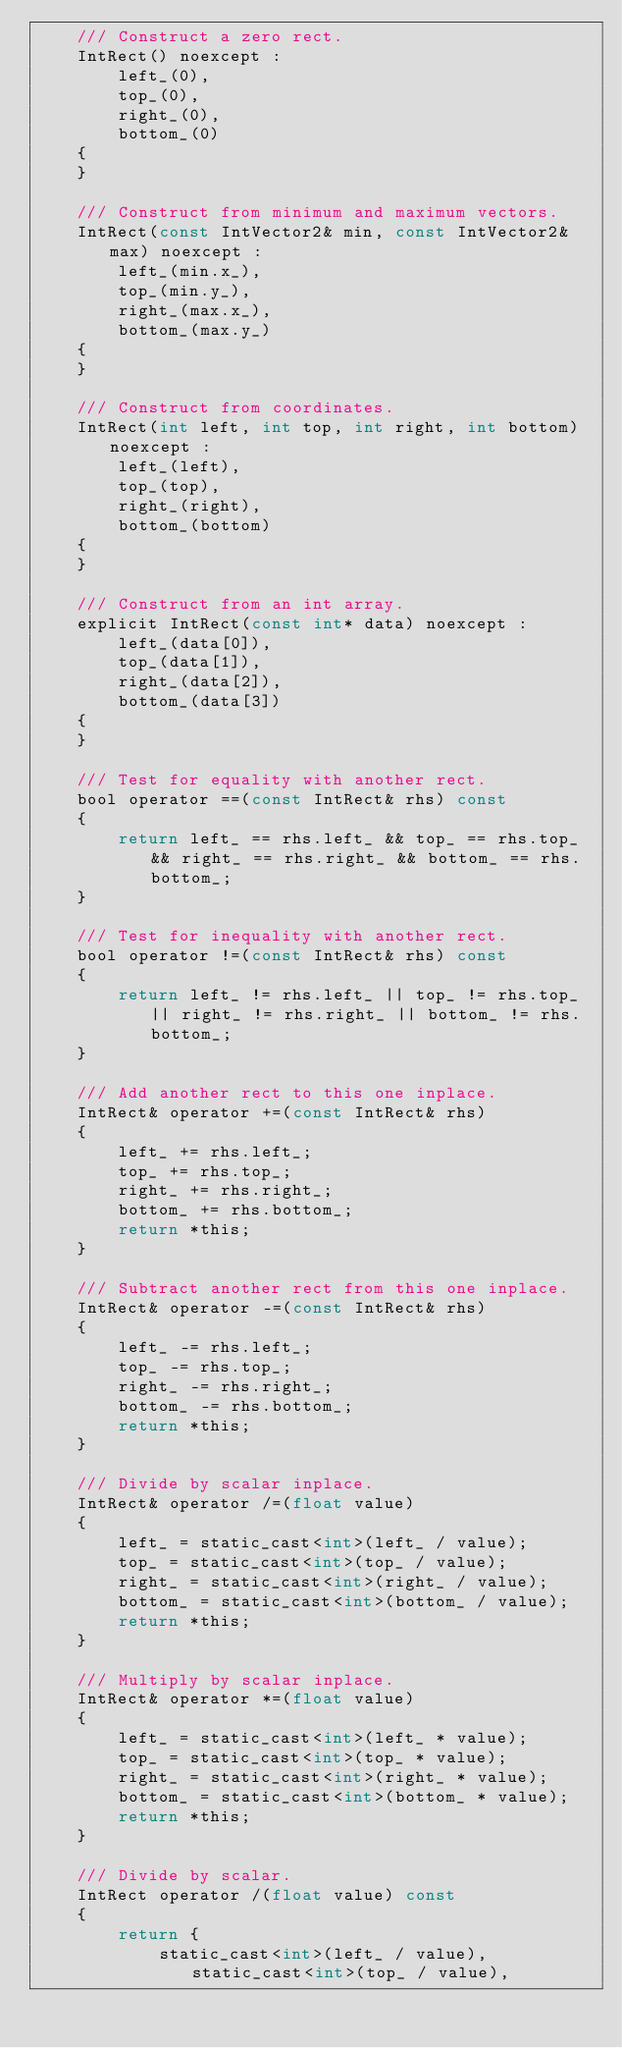<code> <loc_0><loc_0><loc_500><loc_500><_C_>    /// Construct a zero rect.
    IntRect() noexcept :
        left_(0),
        top_(0),
        right_(0),
        bottom_(0)
    {
    }

    /// Construct from minimum and maximum vectors.
    IntRect(const IntVector2& min, const IntVector2& max) noexcept :
        left_(min.x_),
        top_(min.y_),
        right_(max.x_),
        bottom_(max.y_)
    {
    }

    /// Construct from coordinates.
    IntRect(int left, int top, int right, int bottom) noexcept :
        left_(left),
        top_(top),
        right_(right),
        bottom_(bottom)
    {
    }

    /// Construct from an int array.
    explicit IntRect(const int* data) noexcept :
        left_(data[0]),
        top_(data[1]),
        right_(data[2]),
        bottom_(data[3])
    {
    }

    /// Test for equality with another rect.
    bool operator ==(const IntRect& rhs) const
    {
        return left_ == rhs.left_ && top_ == rhs.top_ && right_ == rhs.right_ && bottom_ == rhs.bottom_;
    }

    /// Test for inequality with another rect.
    bool operator !=(const IntRect& rhs) const
    {
        return left_ != rhs.left_ || top_ != rhs.top_ || right_ != rhs.right_ || bottom_ != rhs.bottom_;
    }

    /// Add another rect to this one inplace.
    IntRect& operator +=(const IntRect& rhs)
    {
        left_ += rhs.left_;
        top_ += rhs.top_;
        right_ += rhs.right_;
        bottom_ += rhs.bottom_;
        return *this;
    }

    /// Subtract another rect from this one inplace.
    IntRect& operator -=(const IntRect& rhs)
    {
        left_ -= rhs.left_;
        top_ -= rhs.top_;
        right_ -= rhs.right_;
        bottom_ -= rhs.bottom_;
        return *this;
    }

    /// Divide by scalar inplace.
    IntRect& operator /=(float value)
    {
        left_ = static_cast<int>(left_ / value);
        top_ = static_cast<int>(top_ / value);
        right_ = static_cast<int>(right_ / value);
        bottom_ = static_cast<int>(bottom_ / value);
        return *this;
    }

    /// Multiply by scalar inplace.
    IntRect& operator *=(float value)
    {
        left_ = static_cast<int>(left_ * value);
        top_ = static_cast<int>(top_ * value);
        right_ = static_cast<int>(right_ * value);
        bottom_ = static_cast<int>(bottom_ * value);
        return *this;
    }

    /// Divide by scalar.
    IntRect operator /(float value) const
    {
        return {
            static_cast<int>(left_ / value), static_cast<int>(top_ / value),</code> 